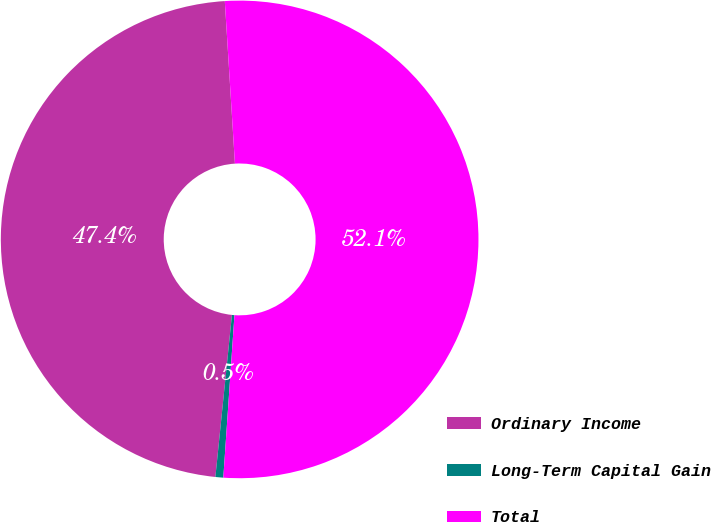Convert chart to OTSL. <chart><loc_0><loc_0><loc_500><loc_500><pie_chart><fcel>Ordinary Income<fcel>Long-Term Capital Gain<fcel>Total<nl><fcel>47.39%<fcel>0.53%<fcel>52.08%<nl></chart> 